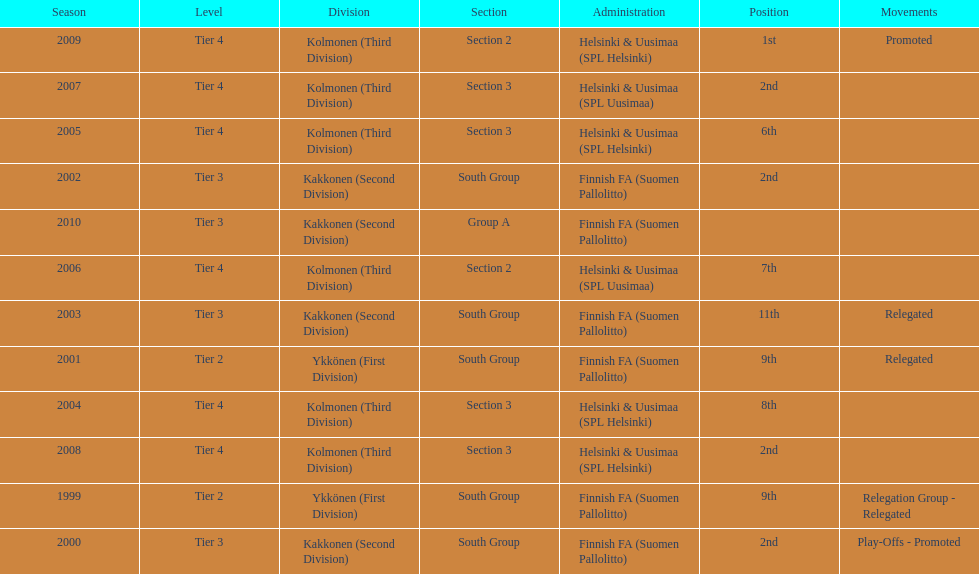How many tiers had more than one relegated movement? 1. 